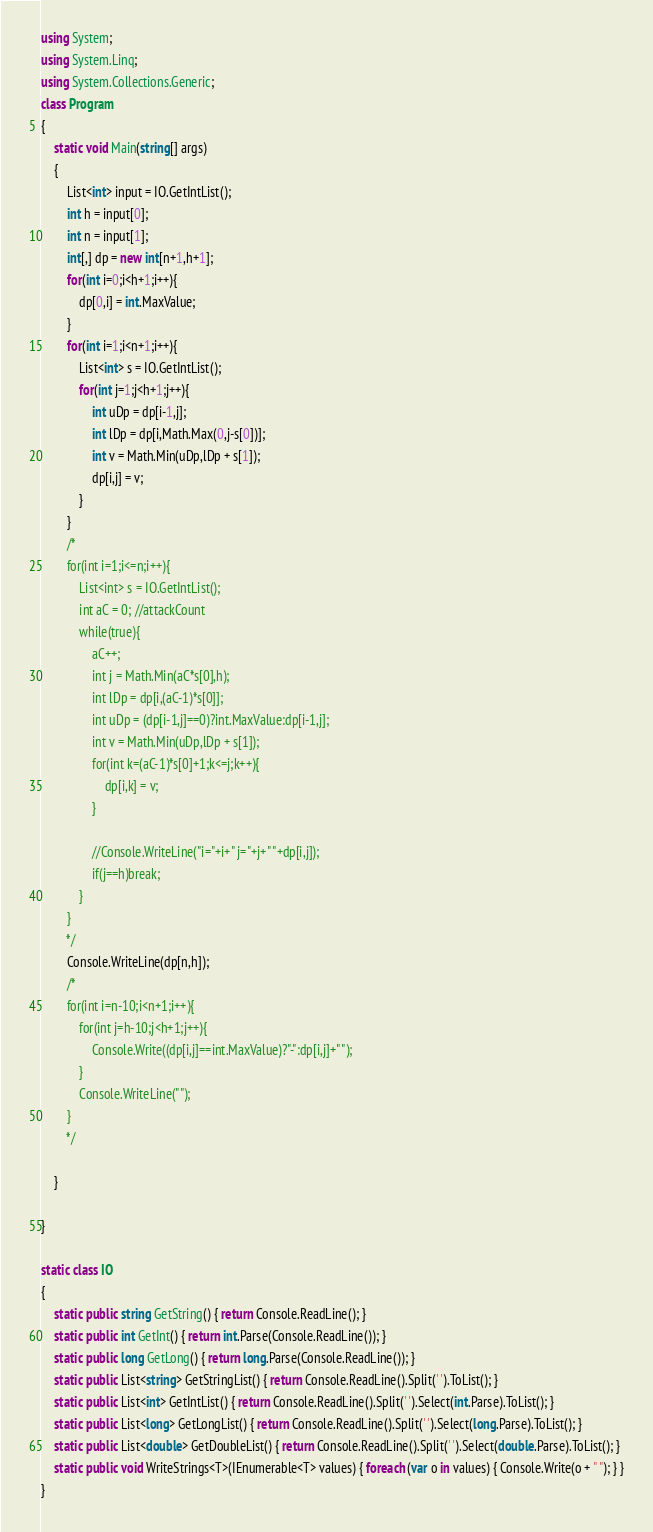Convert code to text. <code><loc_0><loc_0><loc_500><loc_500><_C#_>using System;
using System.Linq;
using System.Collections.Generic;
class Program
{
	static void Main(string[] args)
	{
	    List<int> input = IO.GetIntList();
	    int h = input[0];
	    int n = input[1];
	    int[,] dp = new int[n+1,h+1];
	    for(int i=0;i<h+1;i++){
	        dp[0,i] = int.MaxValue;
	    }
        for(int i=1;i<n+1;i++){
            List<int> s = IO.GetIntList();
            for(int j=1;j<h+1;j++){
                int uDp = dp[i-1,j];
                int lDp = dp[i,Math.Max(0,j-s[0])];
                int v = Math.Min(uDp,lDp + s[1]);
                dp[i,j] = v;
	        }
	    }
	    /*
	    for(int i=1;i<=n;i++){
	        List<int> s = IO.GetIntList();
	        int aC = 0; //attackCount
	        while(true){
	            aC++;
	            int j = Math.Min(aC*s[0],h);
	            int lDp = dp[i,(aC-1)*s[0]];
	            int uDp = (dp[i-1,j]==0)?int.MaxValue:dp[i-1,j];
	            int v = Math.Min(uDp,lDp + s[1]);
	            for(int k=(aC-1)*s[0]+1;k<=j;k++){
	                dp[i,k] = v;
	            }
	            
	            //Console.WriteLine("i="+i+" j="+j+" "+dp[i,j]);
	            if(j==h)break;
	        }
	    }
	    */
	    Console.WriteLine(dp[n,h]);
	    /*
	    for(int i=n-10;i<n+1;i++){
	        for(int j=h-10;j<h+1;j++){
	            Console.Write((dp[i,j]==int.MaxValue)?"-":dp[i,j]+" ");
	        }
	        Console.WriteLine("");
	    }
	    */
	    
	}

}

static class IO
{
    static public string GetString() { return Console.ReadLine(); }
    static public int GetInt() { return int.Parse(Console.ReadLine()); }
    static public long GetLong() { return long.Parse(Console.ReadLine()); }
    static public List<string> GetStringList() { return Console.ReadLine().Split(' ').ToList(); }
    static public List<int> GetIntList() { return Console.ReadLine().Split(' ').Select(int.Parse).ToList(); }
    static public List<long> GetLongList() { return Console.ReadLine().Split(' ').Select(long.Parse).ToList(); }
    static public List<double> GetDoubleList() { return Console.ReadLine().Split(' ').Select(double.Parse).ToList(); }
    static public void WriteStrings<T>(IEnumerable<T> values) { foreach (var o in values) { Console.Write(o + " "); } }
}</code> 